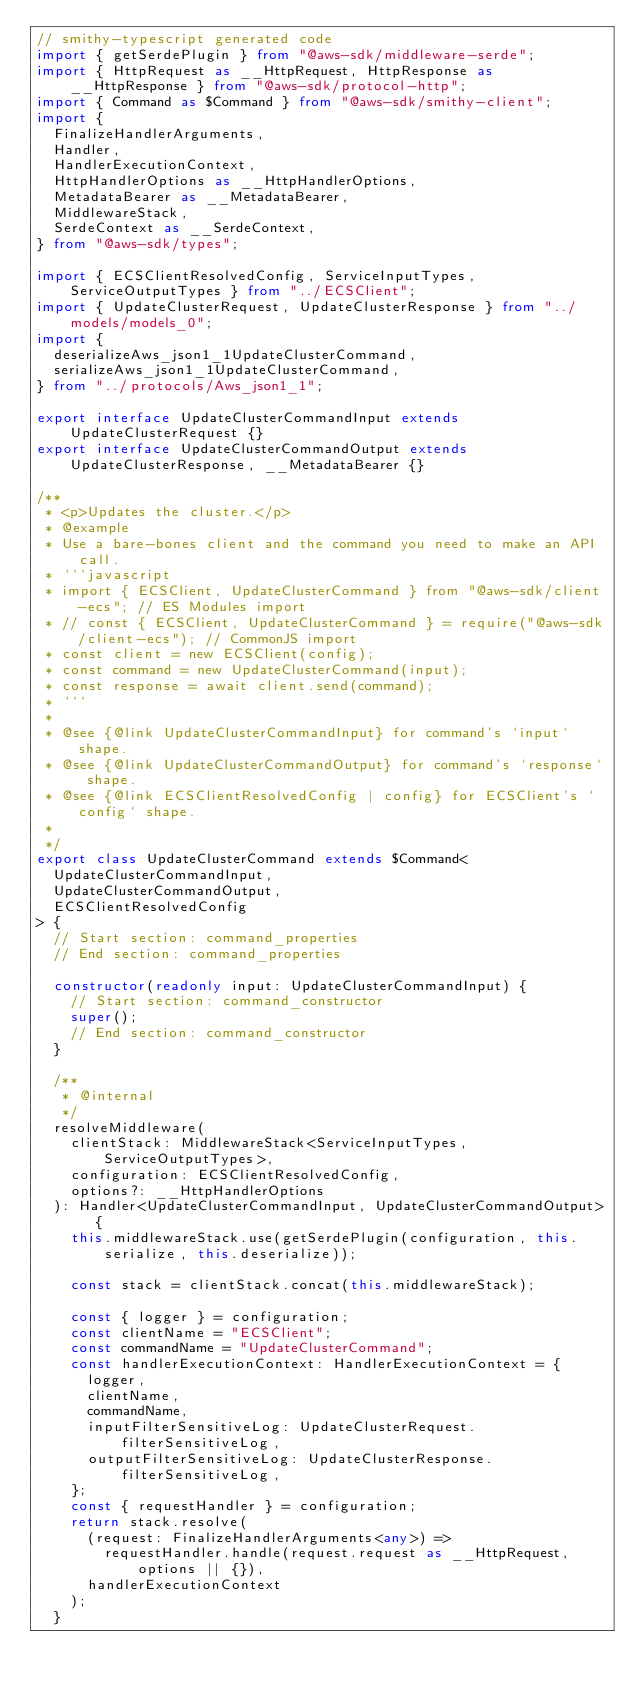<code> <loc_0><loc_0><loc_500><loc_500><_TypeScript_>// smithy-typescript generated code
import { getSerdePlugin } from "@aws-sdk/middleware-serde";
import { HttpRequest as __HttpRequest, HttpResponse as __HttpResponse } from "@aws-sdk/protocol-http";
import { Command as $Command } from "@aws-sdk/smithy-client";
import {
  FinalizeHandlerArguments,
  Handler,
  HandlerExecutionContext,
  HttpHandlerOptions as __HttpHandlerOptions,
  MetadataBearer as __MetadataBearer,
  MiddlewareStack,
  SerdeContext as __SerdeContext,
} from "@aws-sdk/types";

import { ECSClientResolvedConfig, ServiceInputTypes, ServiceOutputTypes } from "../ECSClient";
import { UpdateClusterRequest, UpdateClusterResponse } from "../models/models_0";
import {
  deserializeAws_json1_1UpdateClusterCommand,
  serializeAws_json1_1UpdateClusterCommand,
} from "../protocols/Aws_json1_1";

export interface UpdateClusterCommandInput extends UpdateClusterRequest {}
export interface UpdateClusterCommandOutput extends UpdateClusterResponse, __MetadataBearer {}

/**
 * <p>Updates the cluster.</p>
 * @example
 * Use a bare-bones client and the command you need to make an API call.
 * ```javascript
 * import { ECSClient, UpdateClusterCommand } from "@aws-sdk/client-ecs"; // ES Modules import
 * // const { ECSClient, UpdateClusterCommand } = require("@aws-sdk/client-ecs"); // CommonJS import
 * const client = new ECSClient(config);
 * const command = new UpdateClusterCommand(input);
 * const response = await client.send(command);
 * ```
 *
 * @see {@link UpdateClusterCommandInput} for command's `input` shape.
 * @see {@link UpdateClusterCommandOutput} for command's `response` shape.
 * @see {@link ECSClientResolvedConfig | config} for ECSClient's `config` shape.
 *
 */
export class UpdateClusterCommand extends $Command<
  UpdateClusterCommandInput,
  UpdateClusterCommandOutput,
  ECSClientResolvedConfig
> {
  // Start section: command_properties
  // End section: command_properties

  constructor(readonly input: UpdateClusterCommandInput) {
    // Start section: command_constructor
    super();
    // End section: command_constructor
  }

  /**
   * @internal
   */
  resolveMiddleware(
    clientStack: MiddlewareStack<ServiceInputTypes, ServiceOutputTypes>,
    configuration: ECSClientResolvedConfig,
    options?: __HttpHandlerOptions
  ): Handler<UpdateClusterCommandInput, UpdateClusterCommandOutput> {
    this.middlewareStack.use(getSerdePlugin(configuration, this.serialize, this.deserialize));

    const stack = clientStack.concat(this.middlewareStack);

    const { logger } = configuration;
    const clientName = "ECSClient";
    const commandName = "UpdateClusterCommand";
    const handlerExecutionContext: HandlerExecutionContext = {
      logger,
      clientName,
      commandName,
      inputFilterSensitiveLog: UpdateClusterRequest.filterSensitiveLog,
      outputFilterSensitiveLog: UpdateClusterResponse.filterSensitiveLog,
    };
    const { requestHandler } = configuration;
    return stack.resolve(
      (request: FinalizeHandlerArguments<any>) =>
        requestHandler.handle(request.request as __HttpRequest, options || {}),
      handlerExecutionContext
    );
  }
</code> 